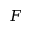Convert formula to latex. <formula><loc_0><loc_0><loc_500><loc_500>F</formula> 